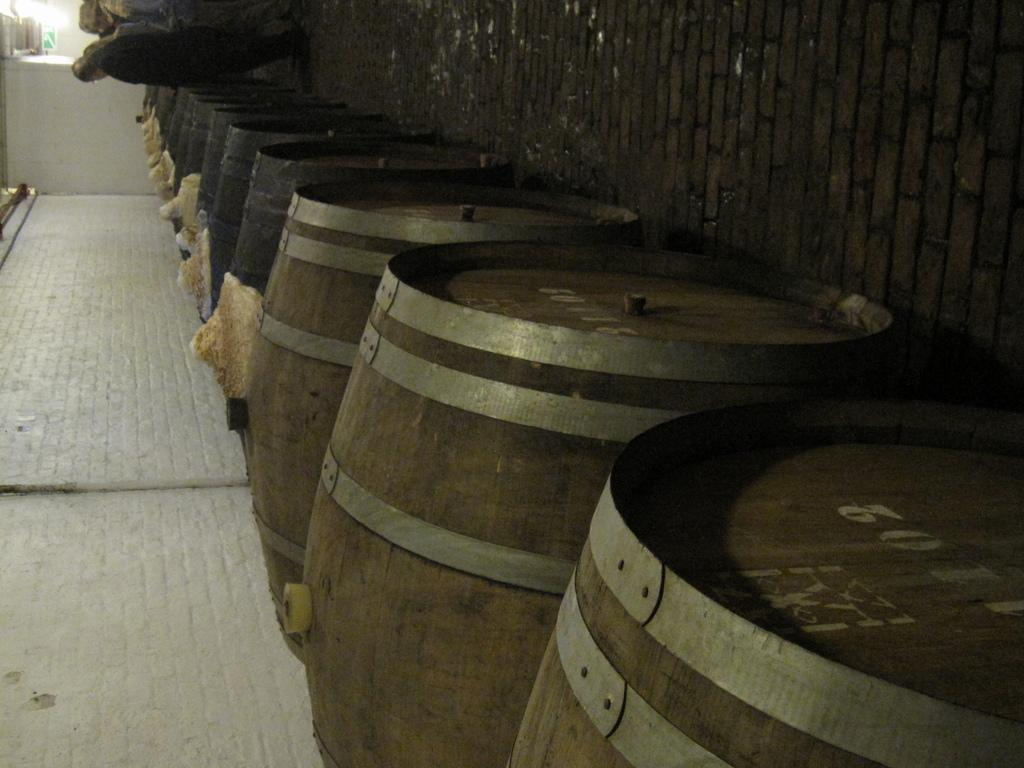<image>
Provide a brief description of the given image. Beer kegs that are brown and silver with numbering on the top including 5011. 